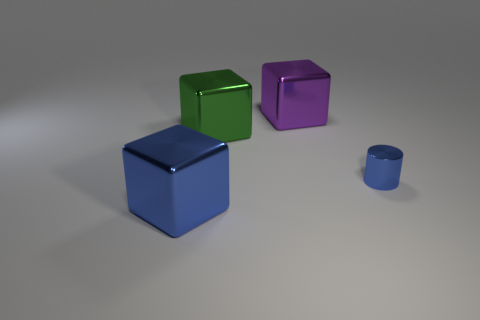Is there any other thing that has the same size as the metallic cylinder?
Give a very brief answer. No. Does the big blue object have the same material as the big purple object?
Give a very brief answer. Yes. What number of other objects are there of the same shape as the small metallic object?
Make the answer very short. 0. There is a cube that is both on the left side of the purple object and behind the big blue thing; what size is it?
Ensure brevity in your answer.  Large. How many matte things are either small cyan balls or blue objects?
Keep it short and to the point. 0. Do the purple thing that is on the left side of the cylinder and the big shiny thing in front of the green shiny object have the same shape?
Offer a very short reply. Yes. Are there any tiny red things that have the same material as the small blue thing?
Your answer should be very brief. No. The tiny metal cylinder has what color?
Ensure brevity in your answer.  Blue. What size is the blue metallic thing on the left side of the blue metal cylinder?
Offer a very short reply. Large. How many other objects are the same color as the small object?
Keep it short and to the point. 1. 